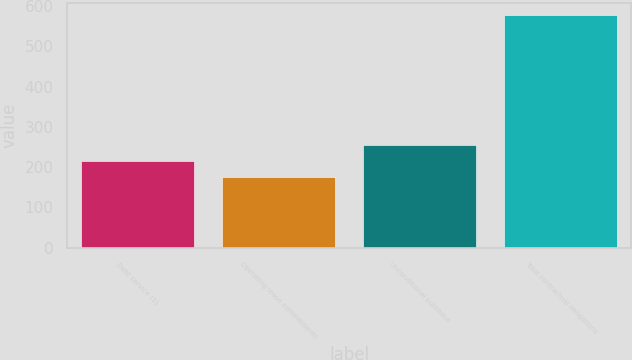Convert chart. <chart><loc_0><loc_0><loc_500><loc_500><bar_chart><fcel>Debt service (1)<fcel>Operating lease commitments<fcel>Unconditional purchase<fcel>Total contractual obligations<nl><fcel>216.03<fcel>175.7<fcel>256.36<fcel>579<nl></chart> 